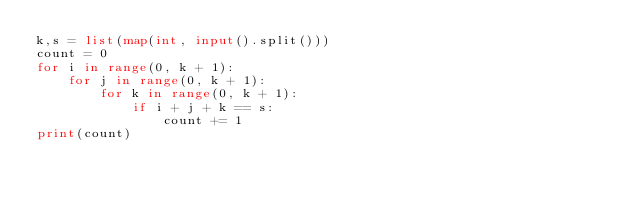<code> <loc_0><loc_0><loc_500><loc_500><_Python_>k,s = list(map(int, input().split()))
count = 0
for i in range(0, k + 1):
    for j in range(0, k + 1):
        for k in range(0, k + 1):
            if i + j + k == s:
                count += 1
print(count)</code> 